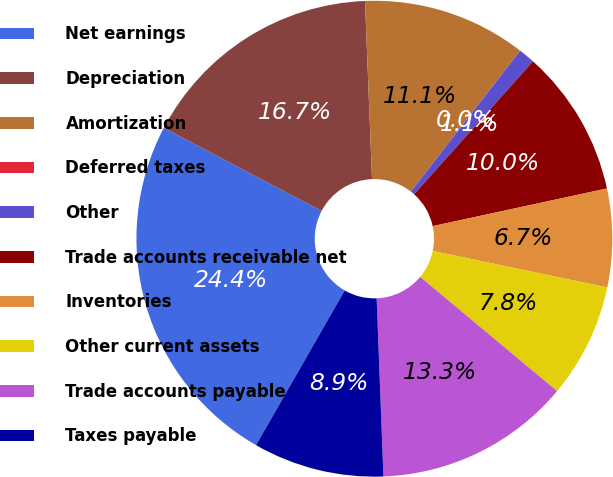Convert chart to OTSL. <chart><loc_0><loc_0><loc_500><loc_500><pie_chart><fcel>Net earnings<fcel>Depreciation<fcel>Amortization<fcel>Deferred taxes<fcel>Other<fcel>Trade accounts receivable net<fcel>Inventories<fcel>Other current assets<fcel>Trade accounts payable<fcel>Taxes payable<nl><fcel>24.43%<fcel>16.66%<fcel>11.11%<fcel>0.01%<fcel>1.12%<fcel>10.0%<fcel>6.67%<fcel>7.78%<fcel>13.33%<fcel>8.89%<nl></chart> 